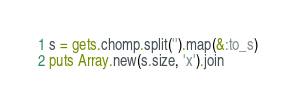Convert code to text. <code><loc_0><loc_0><loc_500><loc_500><_Ruby_>s = gets.chomp.split('').map(&:to_s)
puts Array.new(s.size, 'x').join
</code> 